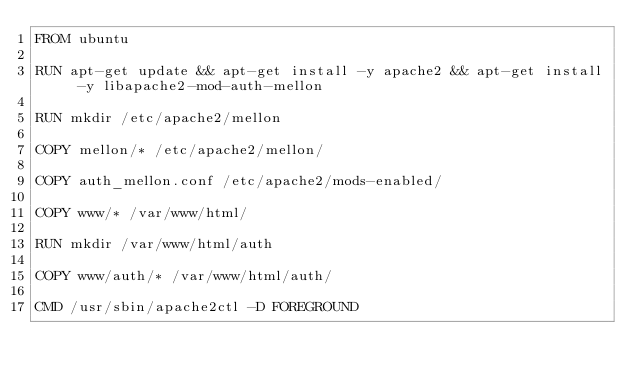Convert code to text. <code><loc_0><loc_0><loc_500><loc_500><_Dockerfile_>FROM ubuntu

RUN apt-get update && apt-get install -y apache2 && apt-get install -y libapache2-mod-auth-mellon

RUN mkdir /etc/apache2/mellon

COPY mellon/* /etc/apache2/mellon/

COPY auth_mellon.conf /etc/apache2/mods-enabled/

COPY www/* /var/www/html/

RUN mkdir /var/www/html/auth

COPY www/auth/* /var/www/html/auth/

CMD /usr/sbin/apache2ctl -D FOREGROUND
</code> 